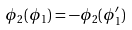Convert formula to latex. <formula><loc_0><loc_0><loc_500><loc_500>\phi _ { 2 } ( \phi _ { 1 } ) = - \phi _ { 2 } ( \phi ^ { \prime } _ { 1 } )</formula> 